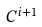<formula> <loc_0><loc_0><loc_500><loc_500>C ^ { i + 1 }</formula> 